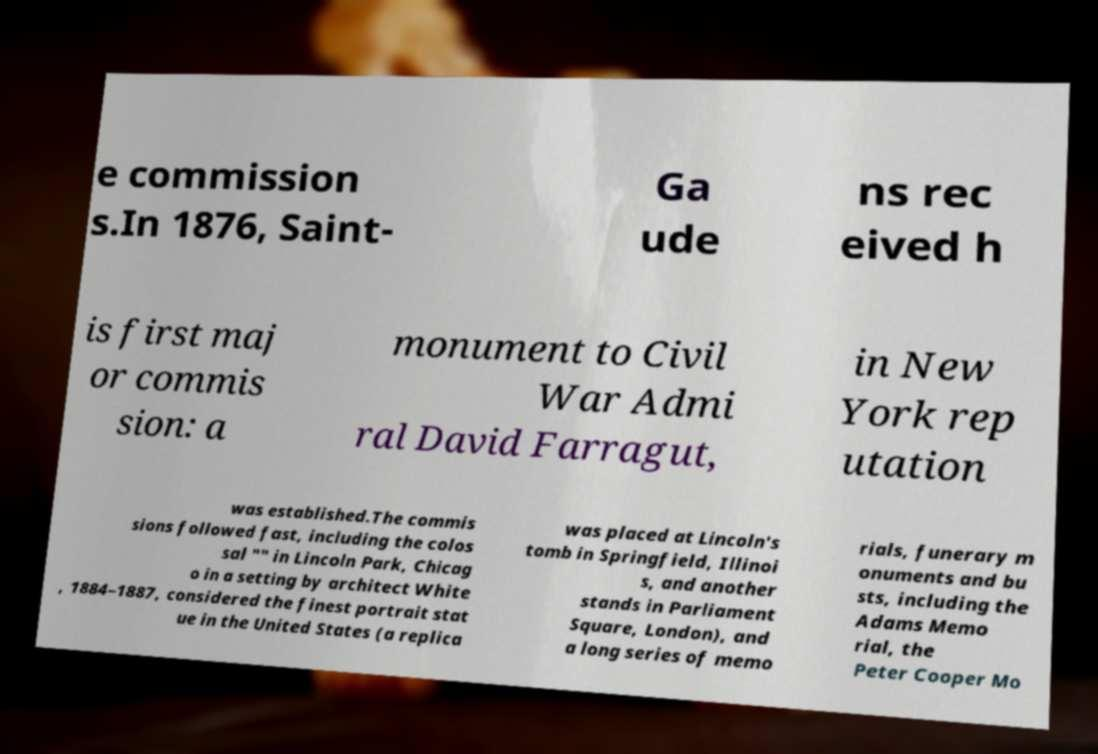Could you assist in decoding the text presented in this image and type it out clearly? e commission s.In 1876, Saint- Ga ude ns rec eived h is first maj or commis sion: a monument to Civil War Admi ral David Farragut, in New York rep utation was established.The commis sions followed fast, including the colos sal "" in Lincoln Park, Chicag o in a setting by architect White , 1884–1887, considered the finest portrait stat ue in the United States (a replica was placed at Lincoln's tomb in Springfield, Illinoi s, and another stands in Parliament Square, London), and a long series of memo rials, funerary m onuments and bu sts, including the Adams Memo rial, the Peter Cooper Mo 